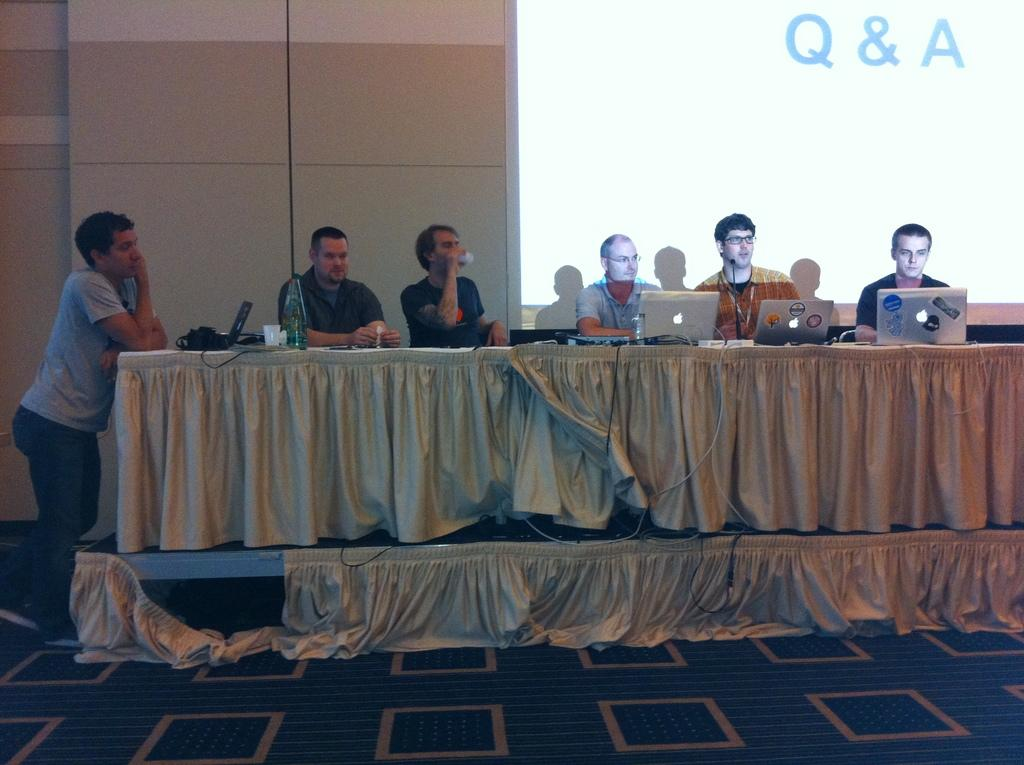How many people are in the image? There is a group of people in the image. What are the people doing in the image? The people are sitting with a table in front of them. What can be seen on the table? There are laptops on the table. Can you describe the person standing in the image? There is a guy standing on the left side of the image. What is displayed on the digital screen? The digital screen displays Q&A. What color is the sun in the image? There is no sun present in the image. How does the heat affect the people in the image? There is no mention of heat in the image, so we cannot determine its effect on the people. 